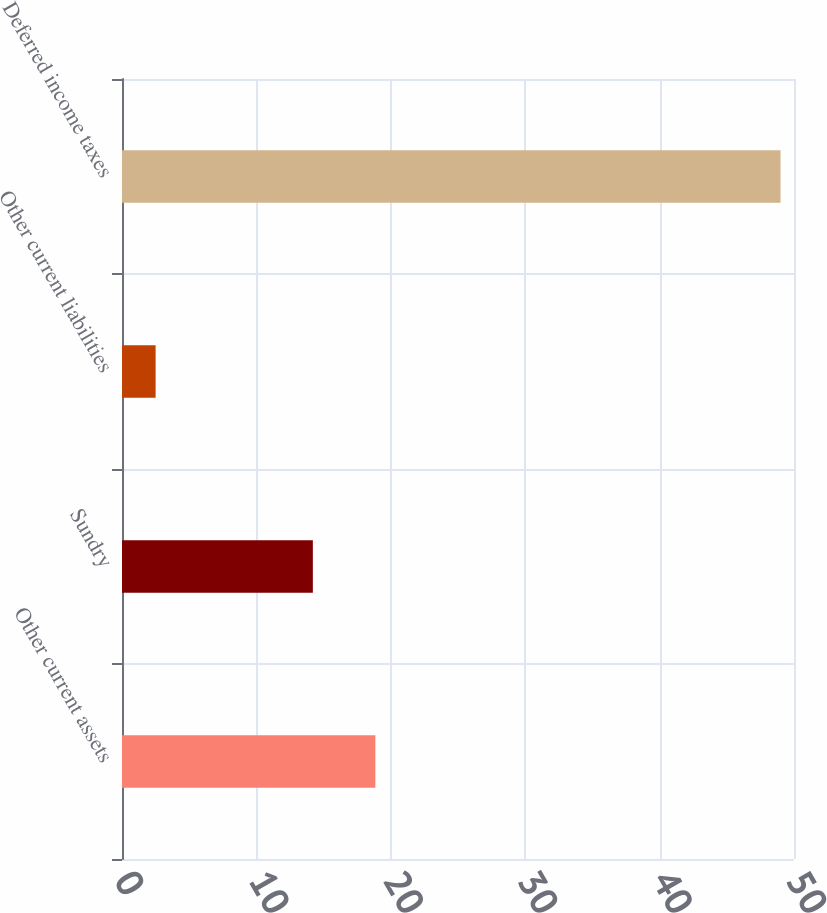Convert chart. <chart><loc_0><loc_0><loc_500><loc_500><bar_chart><fcel>Other current assets<fcel>Sundry<fcel>Other current liabilities<fcel>Deferred income taxes<nl><fcel>18.85<fcel>14.2<fcel>2.5<fcel>49<nl></chart> 